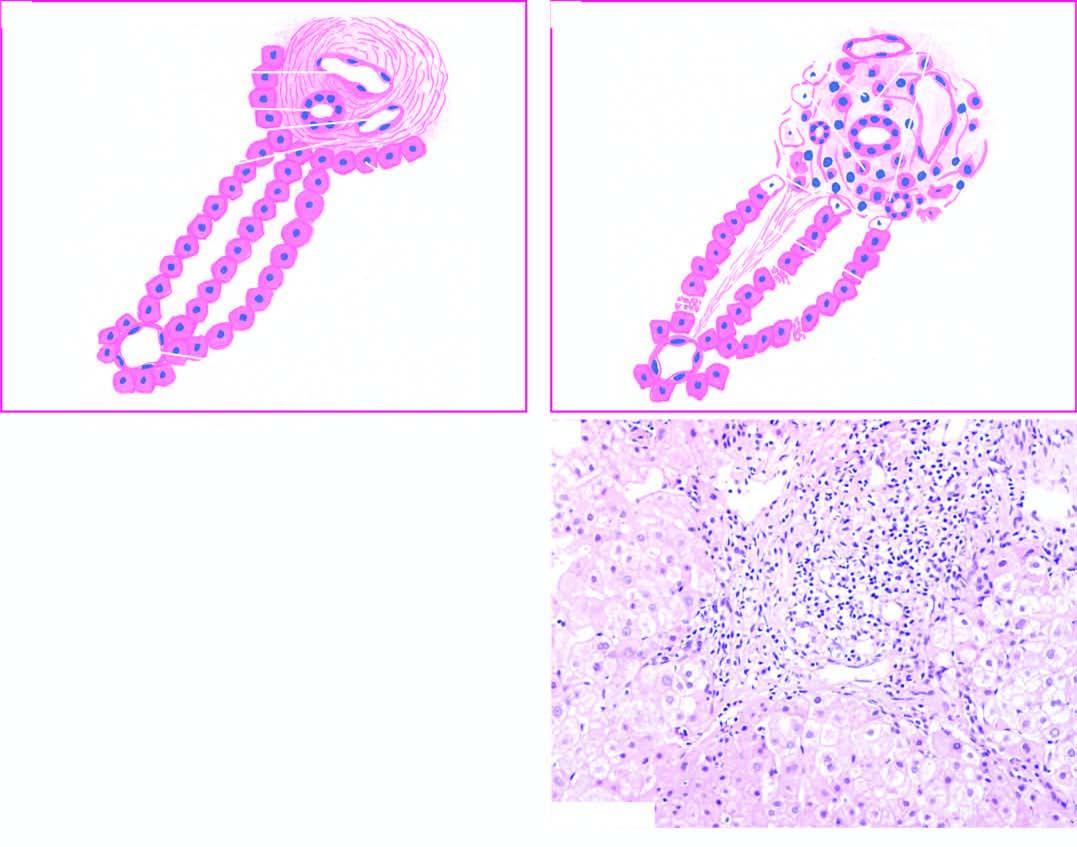what shows stellate-shaped portal triad, with extension of fibrous spurs into lobules?
Answer the question using a single word or phrase. Photomicrograph on right 